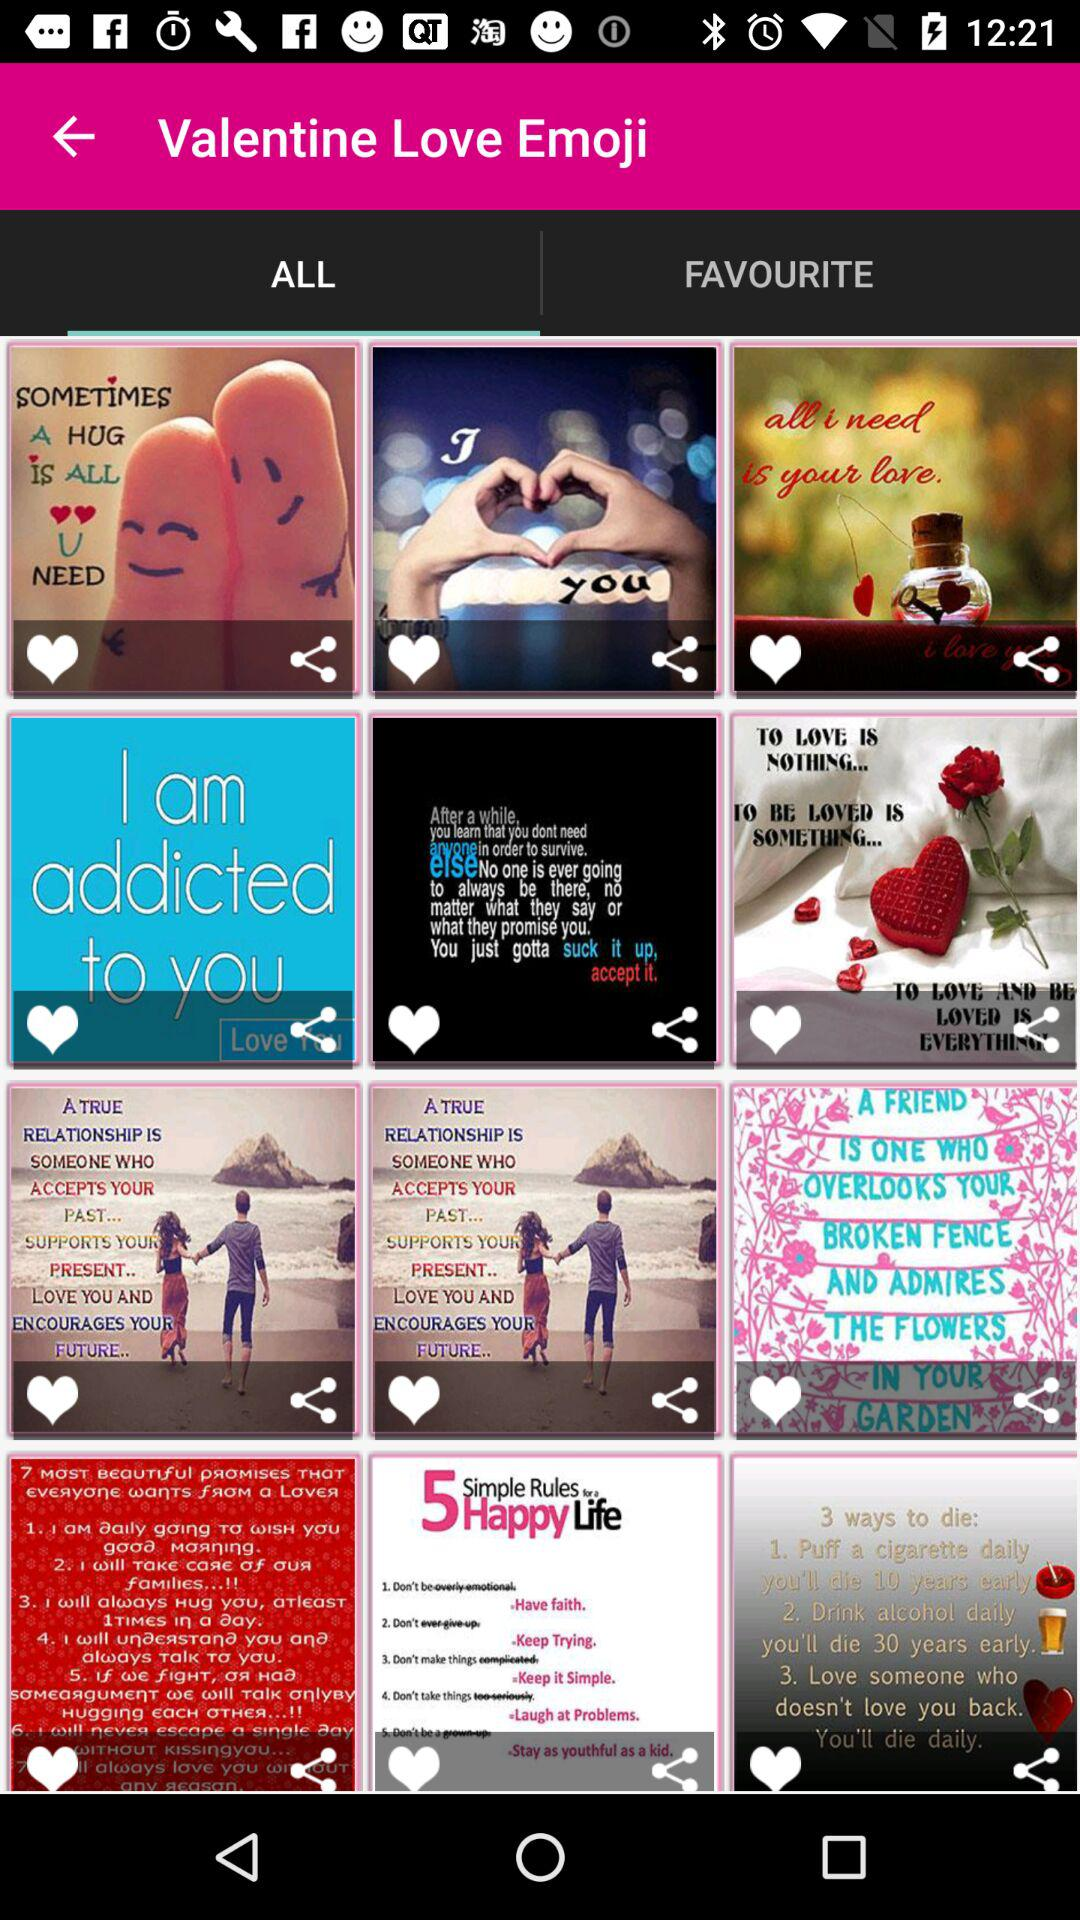Which tab has been selected? The tab that has been selected is "ALL". 